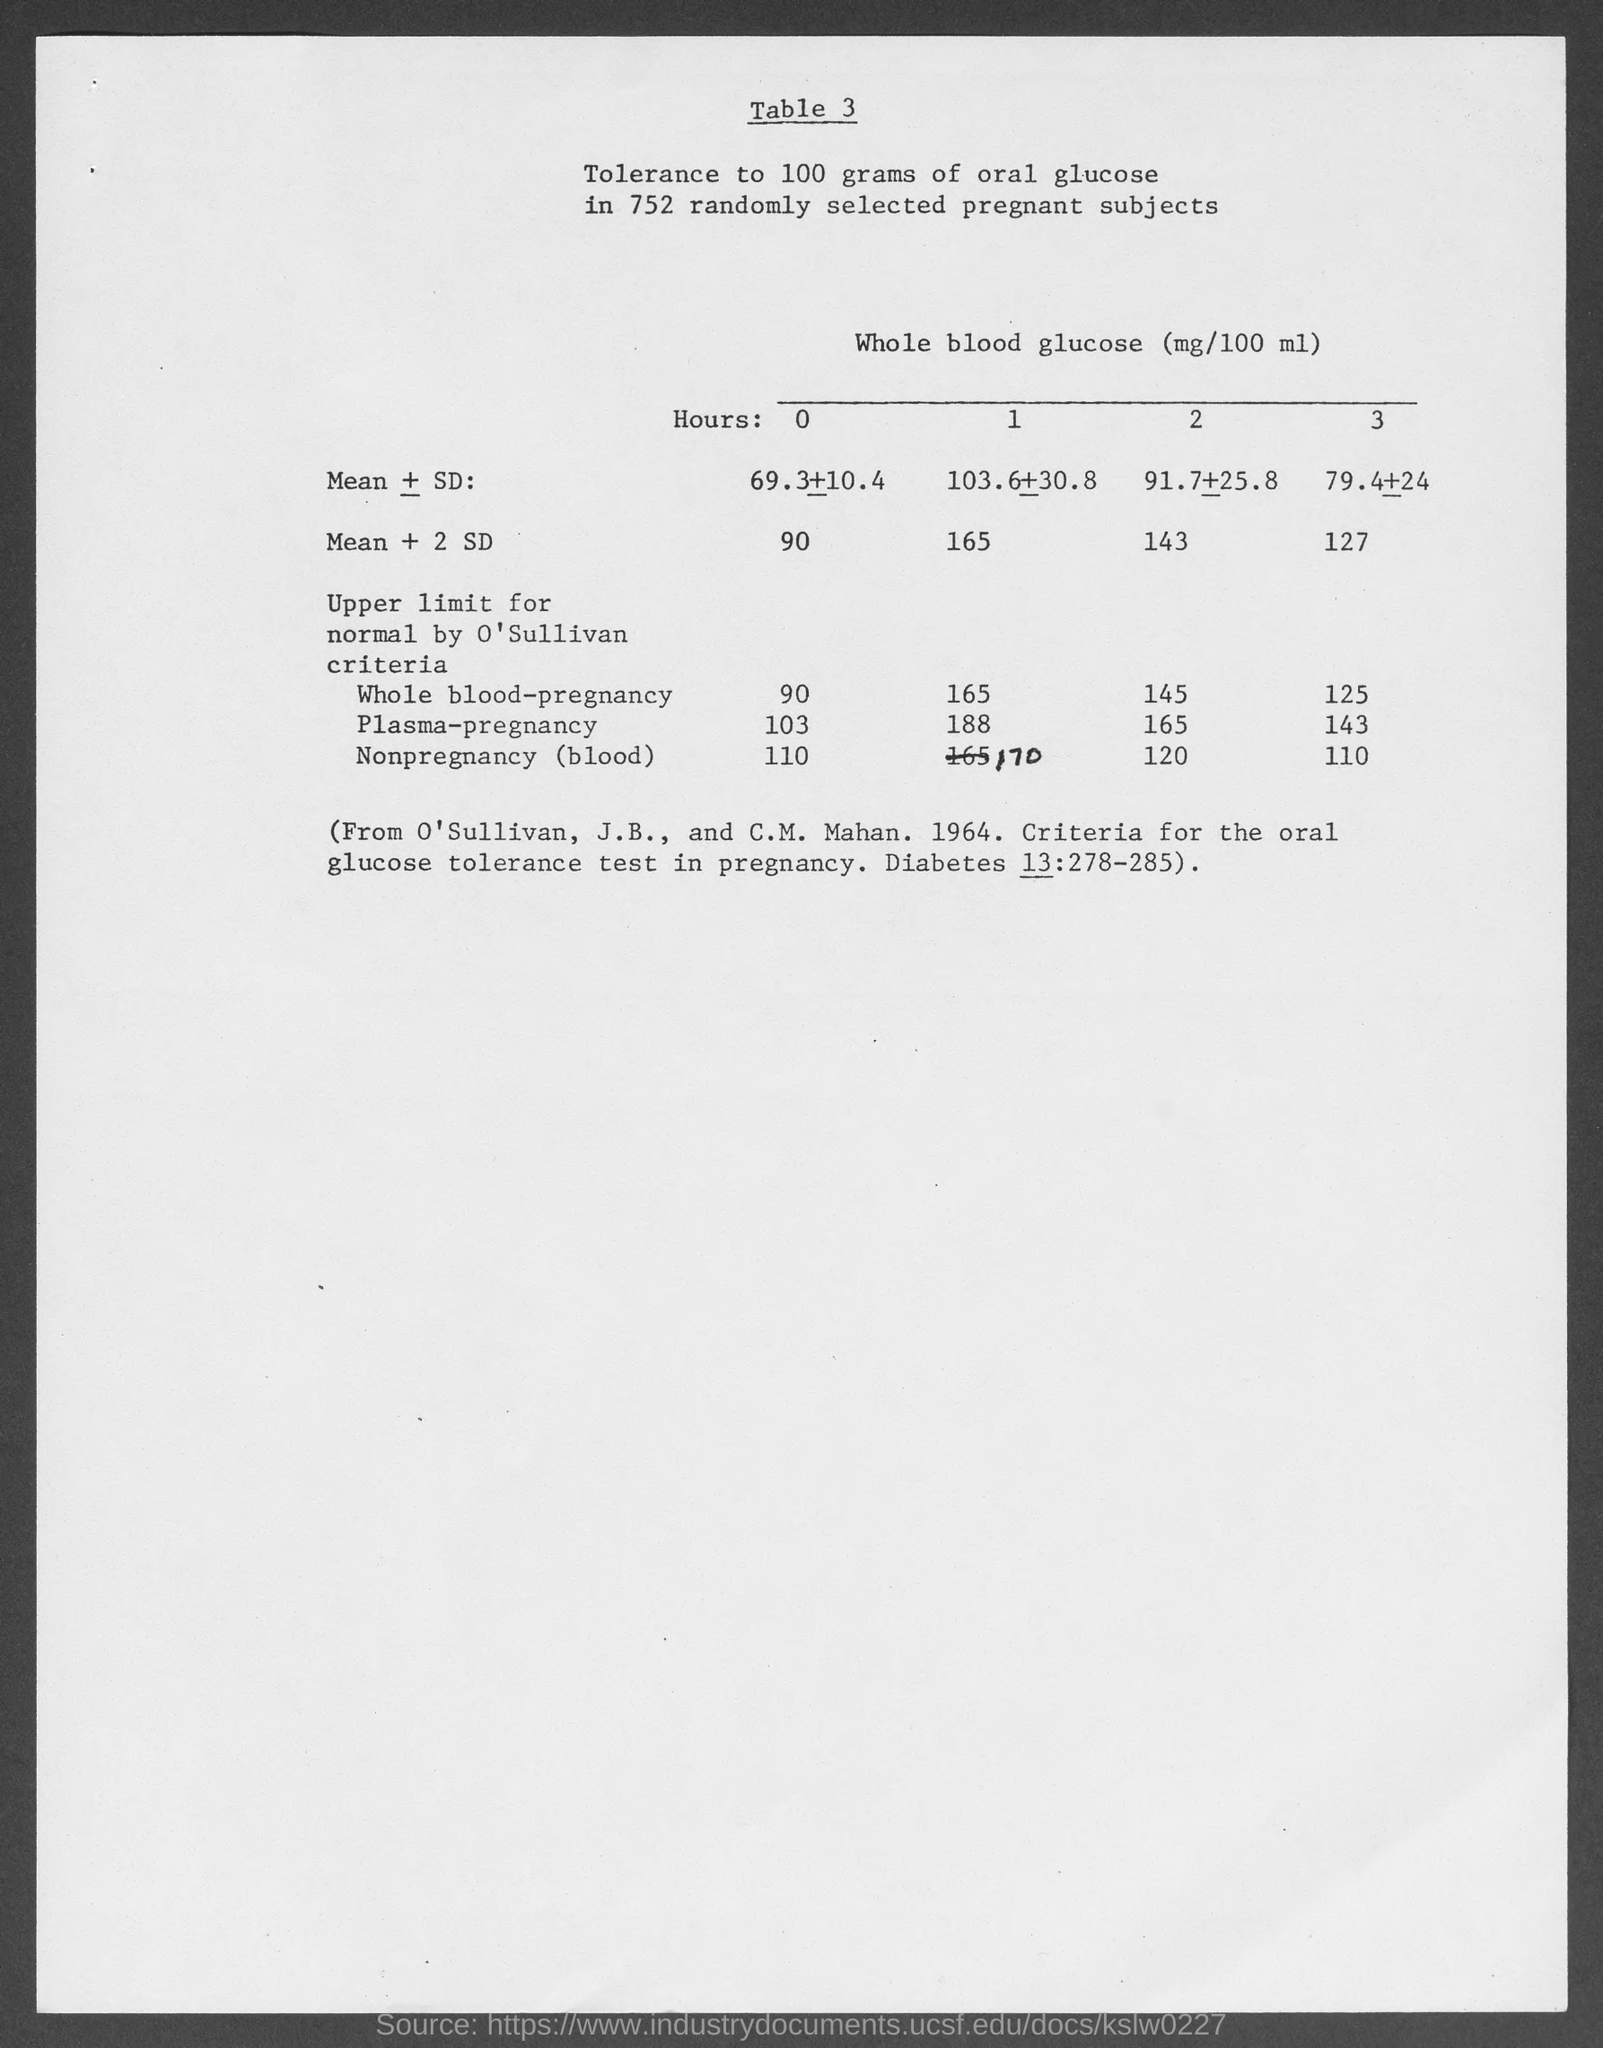Specify some key components in this picture. What is the table number?" is a question that asks for information about a table. The part of the question that comes after "3" is unclear and could be asking for more information. 